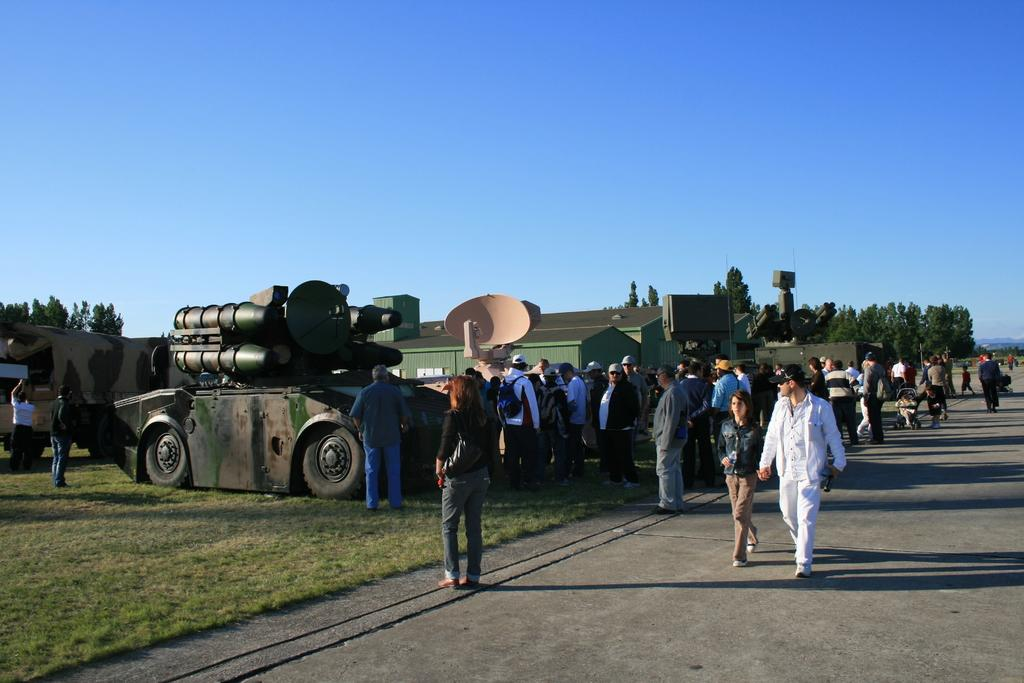Who or what can be seen in the image? There are people in the image. What is located on the left side of the image? There are vehicles and sheds on the left side of the image. What can be seen in the background of the image? There are trees and sky visible in the background of the image. What is at the bottom of the image? There is a road at the bottom of the image. What type of pets are being discussed by the people in the image? There is no indication in the image that the people are discussing pets or any other topic. 